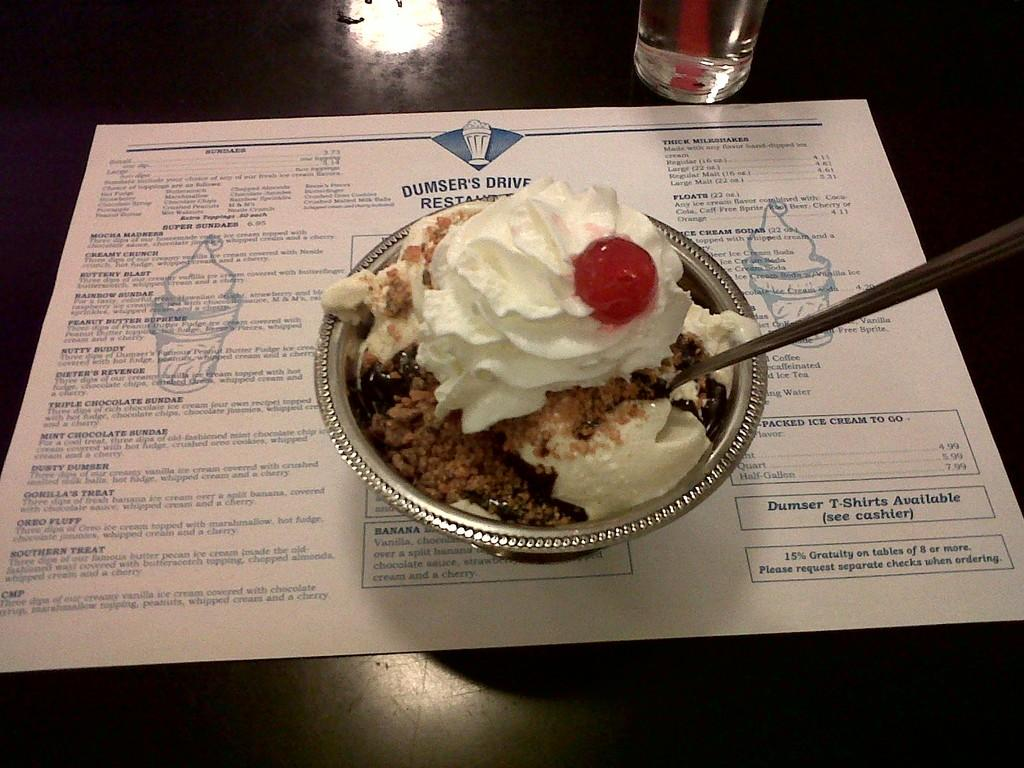What is in the bowl that is visible in the image? There is a bowl with a spoon and ice cream in it. What other items can be seen in the image besides the bowl? There is a paper and a glass visible in the image. Where are the objects placed in the image? The objects are placed on a platform. How many brothers are depicted in the image? There are no brothers depicted in the image; it features a bowl with a spoon and ice cream, a paper, and a glass placed on a platform. 